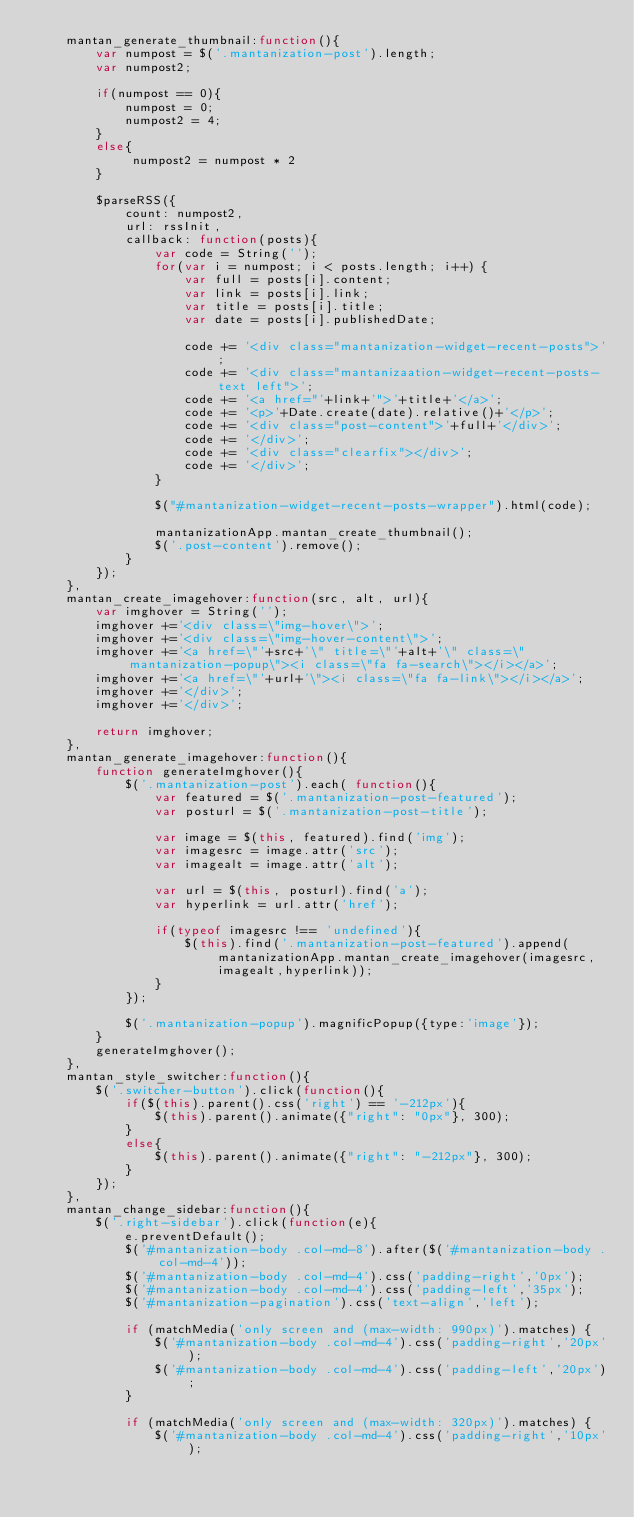<code> <loc_0><loc_0><loc_500><loc_500><_JavaScript_>    mantan_generate_thumbnail:function(){
        var numpost = $('.mantanization-post').length;
        var numpost2;
        
        if(numpost == 0){
            numpost = 0;
            numpost2 = 4;
        }
        else{
             numpost2 = numpost * 2
        }
        
        $parseRSS({
            count: numpost2,
            url: rssInit,
            callback: function(posts){
                var code = String('');
                for(var i = numpost; i < posts.length; i++) {
                    var full = posts[i].content;
                    var link = posts[i].link;
                    var title = posts[i].title;
                    var date = posts[i].publishedDate;

                    code += '<div class="mantanization-widget-recent-posts">';
                    code += '<div class="mantanizaation-widget-recent-posts-text left">';
                    code += '<a href="'+link+'">'+title+'</a>';
                    code += '<p>'+Date.create(date).relative()+'</p>';
                    code += '<div class="post-content">'+full+'</div>';
                    code += '</div>';
                    code += '<div class="clearfix"></div>';
                    code += '</div>';
                }
                
                $("#mantanization-widget-recent-posts-wrapper").html(code);

                mantanizationApp.mantan_create_thumbnail();
                $('.post-content').remove();
            }
        });
    },
    mantan_create_imagehover:function(src, alt, url){
        var imghover = String('');
        imghover +='<div class=\"img-hover\">';
        imghover +='<div class=\"img-hover-content\">';
        imghover +='<a href=\"'+src+'\" title=\"'+alt+'\" class=\"mantanization-popup\"><i class=\"fa fa-search\"></i></a>';
        imghover +='<a href=\"'+url+'\"><i class=\"fa fa-link\"></i></a>';
        imghover +='</div>';
        imghover +='</div>';
                
        return imghover;
    },
    mantan_generate_imagehover:function(){
        function generateImghover(){
            $('.mantanization-post').each( function(){
                var featured = $('.mantanization-post-featured');
                var posturl = $('.mantanization-post-title');
                
                var image = $(this, featured).find('img');
                var imagesrc = image.attr('src');
                var imagealt = image.attr('alt');
                
                var url = $(this, posturl).find('a');
                var hyperlink = url.attr('href');

                if(typeof imagesrc !== 'undefined'){
                    $(this).find('.mantanization-post-featured').append(mantanizationApp.mantan_create_imagehover(imagesrc,imagealt,hyperlink));
                }
            });
            
            $('.mantanization-popup').magnificPopup({type:'image'});
        }
        generateImghover();
    },
    mantan_style_switcher:function(){
        $('.switcher-button').click(function(){
            if($(this).parent().css('right') == '-212px'){
                $(this).parent().animate({"right": "0px"}, 300);
            }
            else{
                $(this).parent().animate({"right": "-212px"}, 300);
            }
        });
    },
    mantan_change_sidebar:function(){
        $('.right-sidebar').click(function(e){
            e.preventDefault();
            $('#mantanization-body .col-md-8').after($('#mantanization-body .col-md-4'));
            $('#mantanization-body .col-md-4').css('padding-right','0px');
            $('#mantanization-body .col-md-4').css('padding-left','35px');
            $('#mantanization-pagination').css('text-align','left');
            
            if (matchMedia('only screen and (max-width: 990px)').matches) {
                $('#mantanization-body .col-md-4').css('padding-right','20px');
                $('#mantanization-body .col-md-4').css('padding-left','20px');
            }
            
            if (matchMedia('only screen and (max-width: 320px)').matches) {
                $('#mantanization-body .col-md-4').css('padding-right','10px');</code> 